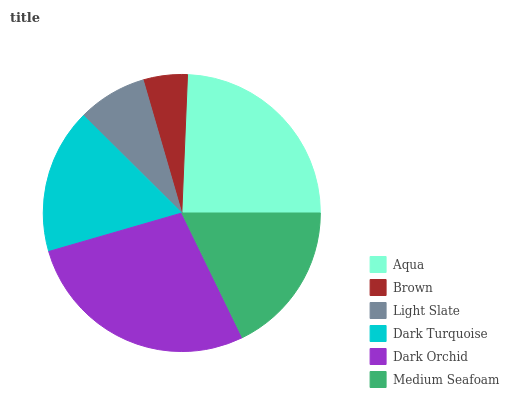Is Brown the minimum?
Answer yes or no. Yes. Is Dark Orchid the maximum?
Answer yes or no. Yes. Is Light Slate the minimum?
Answer yes or no. No. Is Light Slate the maximum?
Answer yes or no. No. Is Light Slate greater than Brown?
Answer yes or no. Yes. Is Brown less than Light Slate?
Answer yes or no. Yes. Is Brown greater than Light Slate?
Answer yes or no. No. Is Light Slate less than Brown?
Answer yes or no. No. Is Medium Seafoam the high median?
Answer yes or no. Yes. Is Dark Turquoise the low median?
Answer yes or no. Yes. Is Brown the high median?
Answer yes or no. No. Is Medium Seafoam the low median?
Answer yes or no. No. 